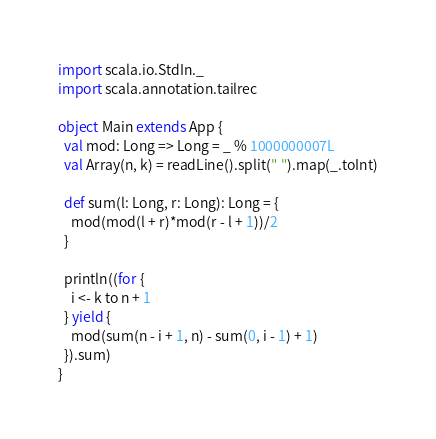Convert code to text. <code><loc_0><loc_0><loc_500><loc_500><_Scala_>import scala.io.StdIn._
import scala.annotation.tailrec

object Main extends App {
  val mod: Long => Long = _ % 1000000007L
  val Array(n, k) = readLine().split(" ").map(_.toInt)

  def sum(l: Long, r: Long): Long = {
    mod(mod(l + r)*mod(r - l + 1))/2
  }

  println((for {
    i <- k to n + 1
  } yield {
    mod(sum(n - i + 1, n) - sum(0, i - 1) + 1)
  }).sum)
}
</code> 